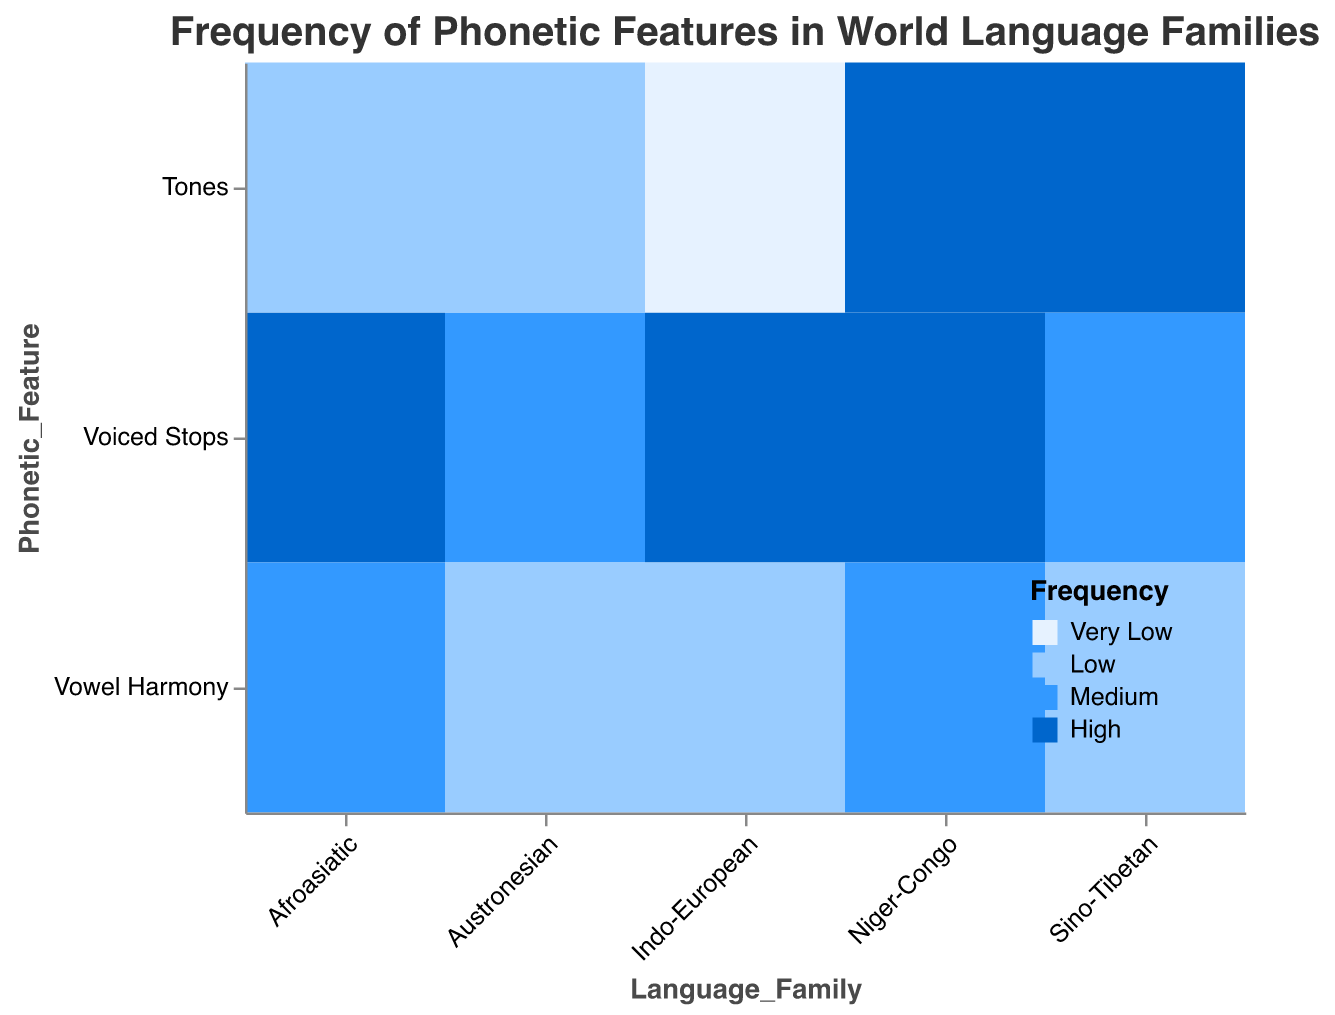What is the frequency of Tones in the Indo-European language family? By looking at the intersection of the "Indo-European" column and the "Tones" row, we see the cell is colored light blue, corresponding to "Very Low" frequency in the legend.
Answer: Very Low What phonetic features have a high frequency in the Niger-Congo language family? By scanning the "Niger-Congo" column, we see that "Voiced Stops" and "Tones" cells are colored dark blue, indicating a "High" frequency.
Answer: Voiced Stops, Tones How does the frequency of Vowel Harmony in Afroasiatic languages compare to Austronesian languages? By comparing the cells for "Vowel Harmony" under both "Afroasiatic" and "Austronesian" columns, we see that Afroasiatic is medium blue (Medium) and Austronesian is light blue (Low).
Answer: Higher Which language family has the highest frequency of Tones? By scanning the "Tones" row, we see that the darkest blue cells are under "Sino-Tibetan" and "Niger-Congo", which both have a "High" frequency.
Answer: Sino-Tibetan, Niger-Congo Is Vowel Harmony more common in Niger-Congo or Indo-European language families? By looking at the "Vowel Harmony" rows under both "Niger-Congo" and "Indo-European" columns, Niger-Congo is medium blue (Medium) and Indo-European is light blue (Low).
Answer: Niger-Congo What phonetic feature in the Sino-Tibetan language family has the lowest frequency? By looking at the "Sino-Tibetan" column, "Vowel Harmony" is the light blue (Low) among all features in this family.
Answer: Vowel Harmony How do the frequencies of Voiced Stops vary across different language families? By examining the cells for "Voiced Stops" across all columns: Indo-European (High), Sino-Tibetan (Medium), Niger-Congo (High), Austronesian (Medium), Afroasiatic (High).
Answer: Indo-European, Niger-Congo, Afroasiatic (High); Sino-Tibetan, Austronesian (Medium) Which phonetic feature in Indo-European languages has the lowest frequency? By scanning the "Indo-European" column, the "Tones" cell is very light blue, representing "Very Low" frequency.
Answer: Tones 